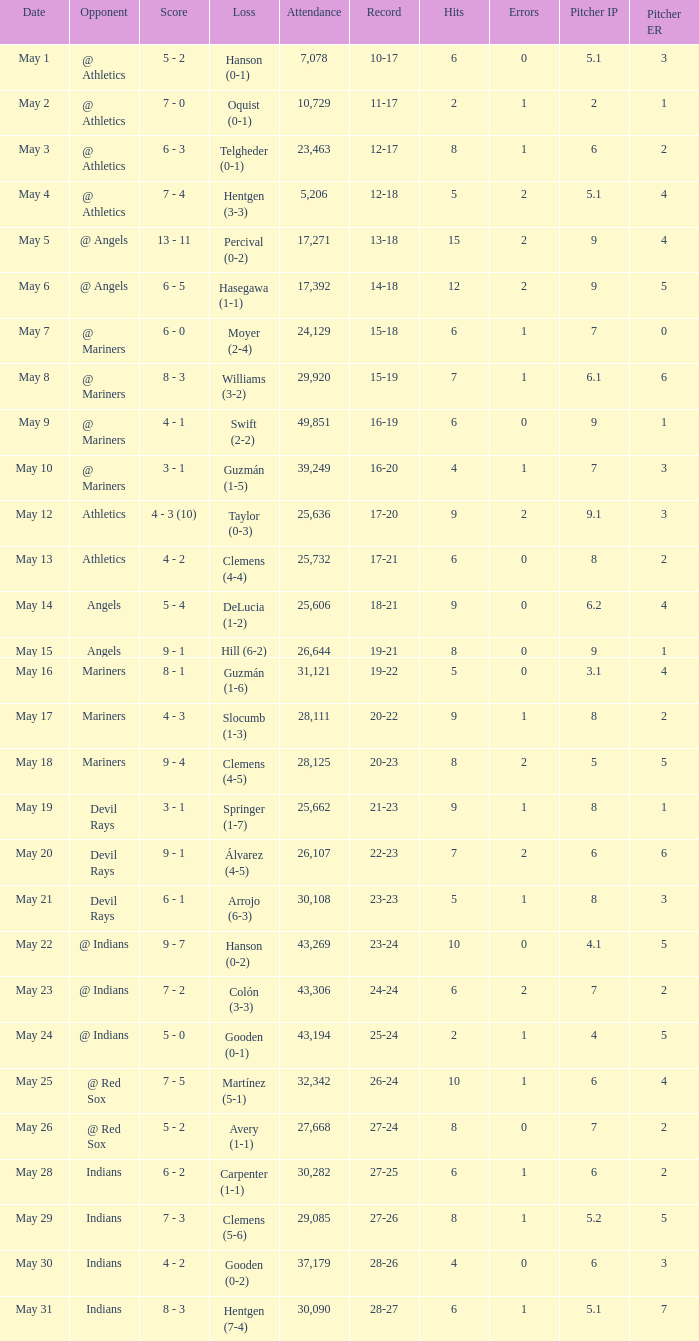Who lost on May 31? Hentgen (7-4). 